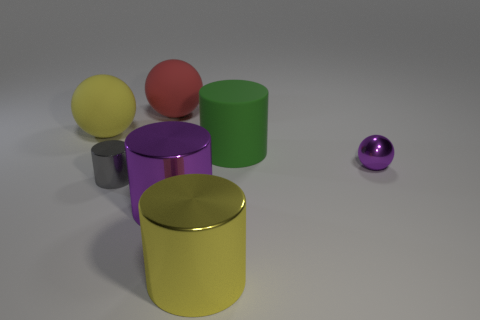Can you describe the positioning of the cylinders in relation to each other? Certainly! In the image, there are three cylinders aligned roughly in a diagonal line from the lower left to the upper right of the frame. The yellow cylinder is at the front and slightly to the left; the green cylinder is behind and to the right of the yellow one, and the magenta cylinder is further to the right and slightly behind the green one. 